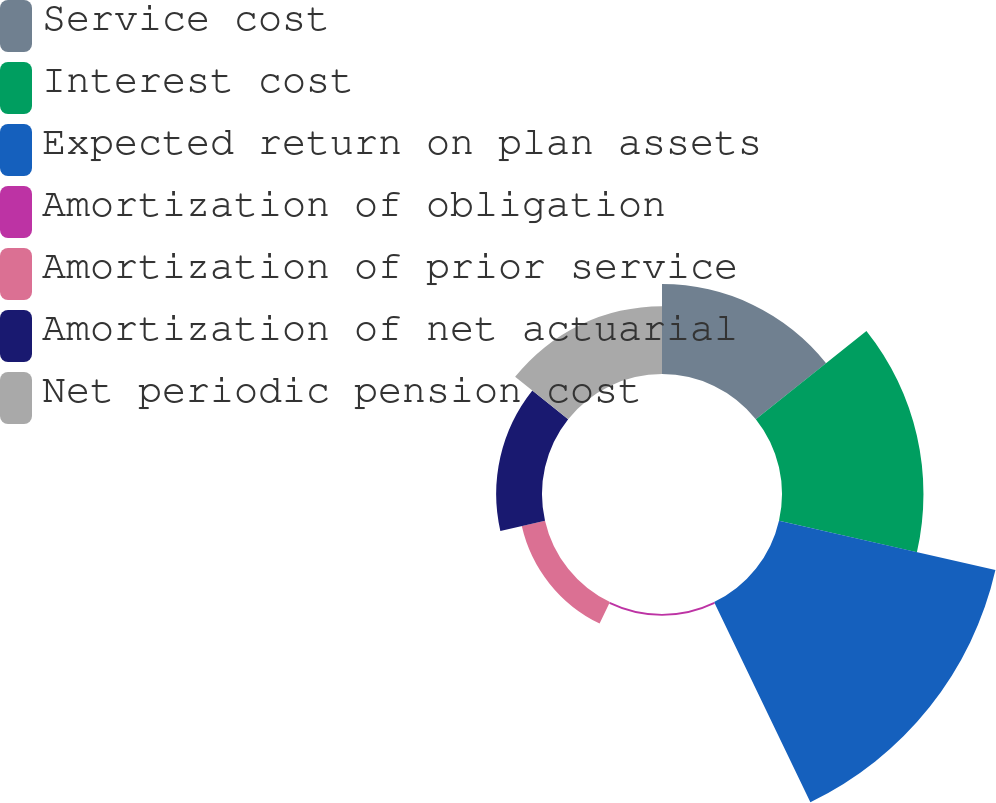Convert chart to OTSL. <chart><loc_0><loc_0><loc_500><loc_500><pie_chart><fcel>Service cost<fcel>Interest cost<fcel>Expected return on plan assets<fcel>Amortization of obligation<fcel>Amortization of prior service<fcel>Amortization of net actuarial<fcel>Net periodic pension cost<nl><fcel>15.17%<fcel>23.87%<fcel>37.46%<fcel>0.3%<fcel>4.02%<fcel>7.73%<fcel>11.45%<nl></chart> 